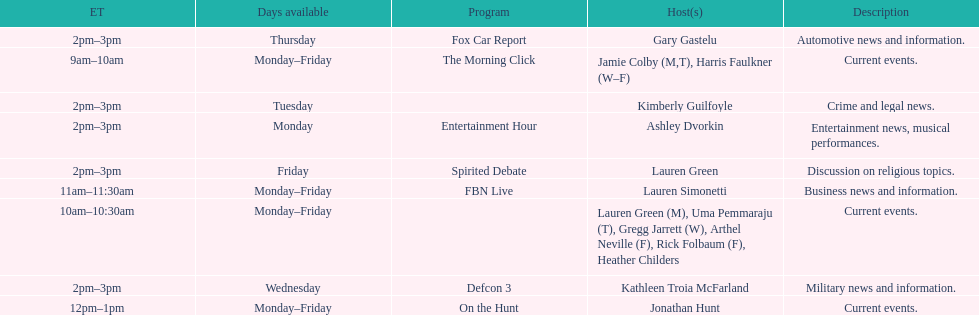How many days during the week does the show fbn live air? 5. 